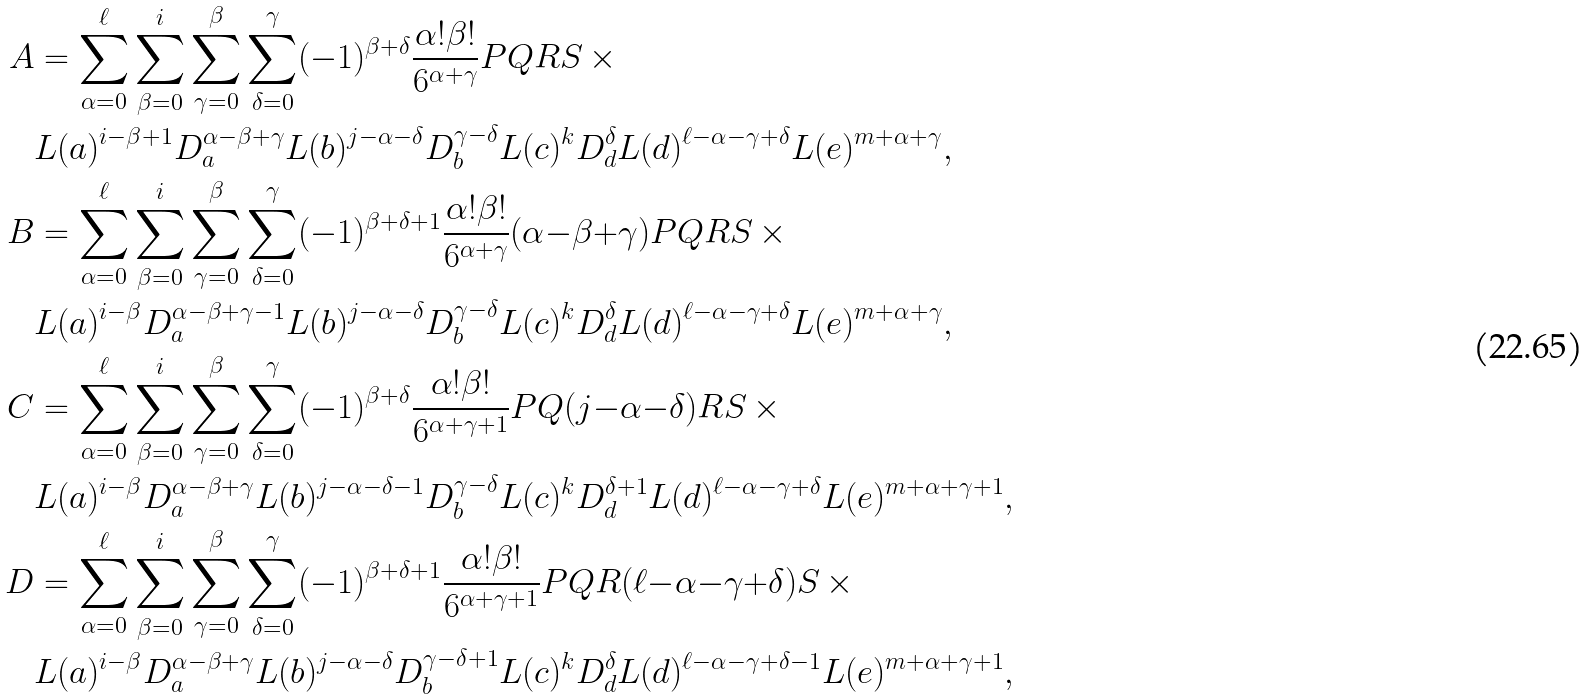Convert formula to latex. <formula><loc_0><loc_0><loc_500><loc_500>A & = \sum _ { \alpha = 0 } ^ { \ell } \sum _ { \beta = 0 } ^ { i } \sum _ { \gamma = 0 } ^ { \beta } \sum _ { \delta = 0 } ^ { \gamma } ( - 1 ) ^ { \beta + \delta } \frac { \alpha ! \beta ! } { 6 ^ { \alpha + \gamma } } P Q R S \, \times \\ & L ( a ) ^ { i - \beta + 1 } D _ { a } ^ { \alpha - \beta + \gamma } L ( b ) ^ { j - \alpha - \delta } D _ { b } ^ { \gamma - \delta } L ( c ) ^ { k } D _ { d } ^ { \delta } L ( d ) ^ { \ell - \alpha - \gamma + \delta } L ( e ) ^ { m + \alpha + \gamma } , \\ B & = \sum _ { \alpha = 0 } ^ { \ell } \sum _ { \beta = 0 } ^ { i } \sum _ { \gamma = 0 } ^ { \beta } \sum _ { \delta = 0 } ^ { \gamma } ( - 1 ) ^ { \beta + \delta + 1 } \frac { \alpha ! \beta ! } { 6 ^ { \alpha + \gamma } } ( \alpha { - } \beta { + } \gamma ) P Q R S \, \times \\ & L ( a ) ^ { i - \beta } D _ { a } ^ { \alpha - \beta + \gamma - 1 } L ( b ) ^ { j - \alpha - \delta } D _ { b } ^ { \gamma - \delta } L ( c ) ^ { k } D _ { d } ^ { \delta } L ( d ) ^ { \ell - \alpha - \gamma + \delta } L ( e ) ^ { m + \alpha + \gamma } , \\ C & = \sum _ { \alpha = 0 } ^ { \ell } \sum _ { \beta = 0 } ^ { i } \sum _ { \gamma = 0 } ^ { \beta } \sum _ { \delta = 0 } ^ { \gamma } ( - 1 ) ^ { \beta + \delta } \frac { \alpha ! \beta ! } { 6 ^ { \alpha + \gamma + 1 } } P Q ( j { - } \alpha { - } \delta ) R S \, \times \\ & L ( a ) ^ { i - \beta } D _ { a } ^ { \alpha - \beta + \gamma } L ( b ) ^ { j - \alpha - \delta - 1 } D _ { b } ^ { \gamma - \delta } L ( c ) ^ { k } D _ { d } ^ { \delta + 1 } L ( d ) ^ { \ell - \alpha - \gamma + \delta } L ( e ) ^ { m + \alpha + \gamma + 1 } , \\ D & = \sum _ { \alpha = 0 } ^ { \ell } \sum _ { \beta = 0 } ^ { i } \sum _ { \gamma = 0 } ^ { \beta } \sum _ { \delta = 0 } ^ { \gamma } ( - 1 ) ^ { \beta + \delta + 1 } \frac { \alpha ! \beta ! } { 6 ^ { \alpha + \gamma + 1 } } P Q R ( \ell { - } \alpha { - } \gamma { + } \delta ) S \, \times \\ & L ( a ) ^ { i - \beta } D _ { a } ^ { \alpha - \beta + \gamma } L ( b ) ^ { j - \alpha - \delta } D _ { b } ^ { \gamma - \delta + 1 } L ( c ) ^ { k } D _ { d } ^ { \delta } L ( d ) ^ { \ell - \alpha - \gamma + \delta - 1 } L ( e ) ^ { m + \alpha + \gamma + 1 } ,</formula> 